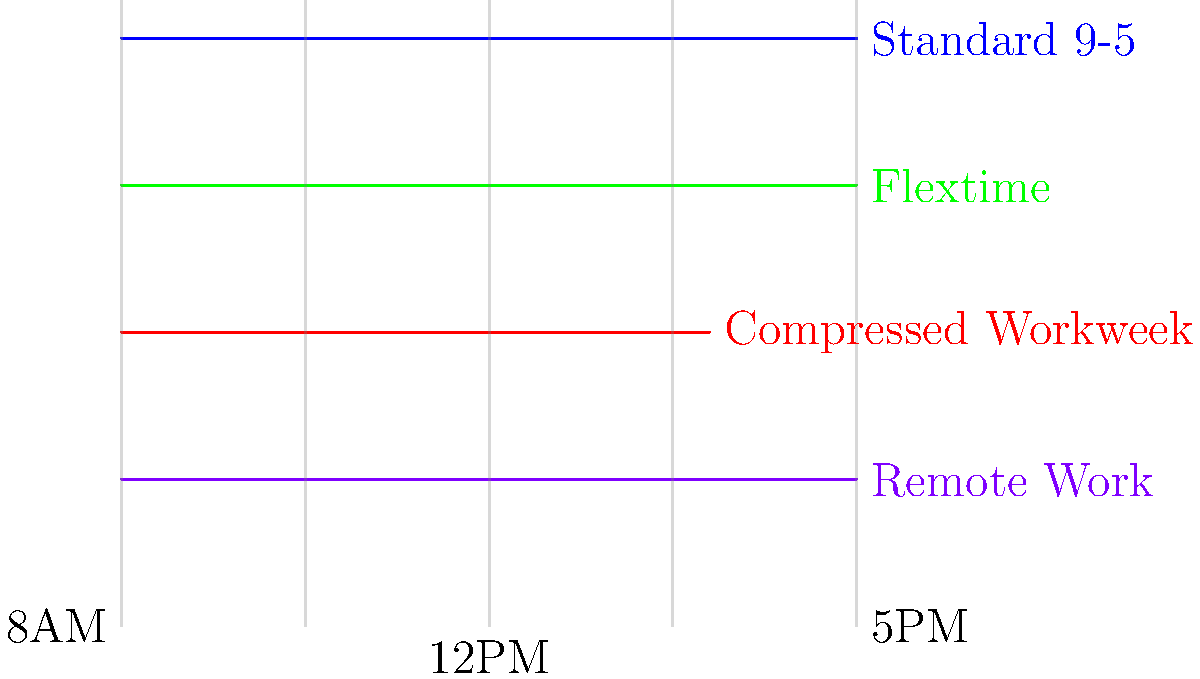As an employer who values employee dedication and accommodates their needs, which flexible work schedule option shown in the timeline would be most beneficial for an employee who has childcare responsibilities in the late afternoon? To answer this question, let's analyze each flexible work schedule option presented in the timeline:

1. Standard 9-5 (Blue):
   This is the traditional work schedule, which may not be ideal for employees with late afternoon childcare responsibilities.

2. Flextime (Green):
   This option allows employees to choose their start and end times within certain limits. It could be beneficial for employees who need to leave earlier in the afternoon.

3. Compressed Workweek (Red):
   This schedule typically involves working longer hours on fewer days. While it might provide some full days off, it may not address daily late afternoon childcare needs.

4. Remote Work (Purple):
   This option allows employees to work from home or another location outside the office. It provides the most flexibility for managing childcare responsibilities.

Considering the employee's need for late afternoon childcare:

- Flextime would allow the employee to start earlier and finish earlier, potentially accommodating their childcare schedule.
- Remote Work would provide the most flexibility, allowing the employee to be present for childcare while still completing their work.

Between these two, Remote Work offers the greatest adaptability for daily childcare needs, as it eliminates commute time and allows for quick transitions between work and childcare responsibilities.
Answer: Remote Work 